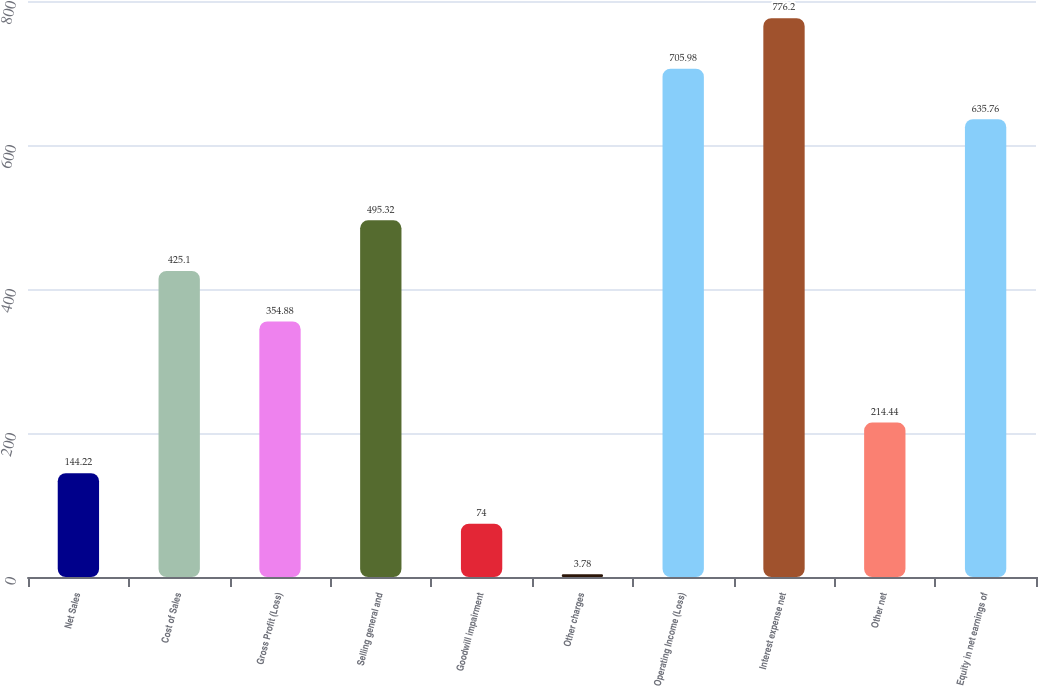<chart> <loc_0><loc_0><loc_500><loc_500><bar_chart><fcel>Net Sales<fcel>Cost of Sales<fcel>Gross Profit (Loss)<fcel>Selling general and<fcel>Goodwill impairment<fcel>Other charges<fcel>Operating Income (Loss)<fcel>Interest expense net<fcel>Other net<fcel>Equity in net earnings of<nl><fcel>144.22<fcel>425.1<fcel>354.88<fcel>495.32<fcel>74<fcel>3.78<fcel>705.98<fcel>776.2<fcel>214.44<fcel>635.76<nl></chart> 